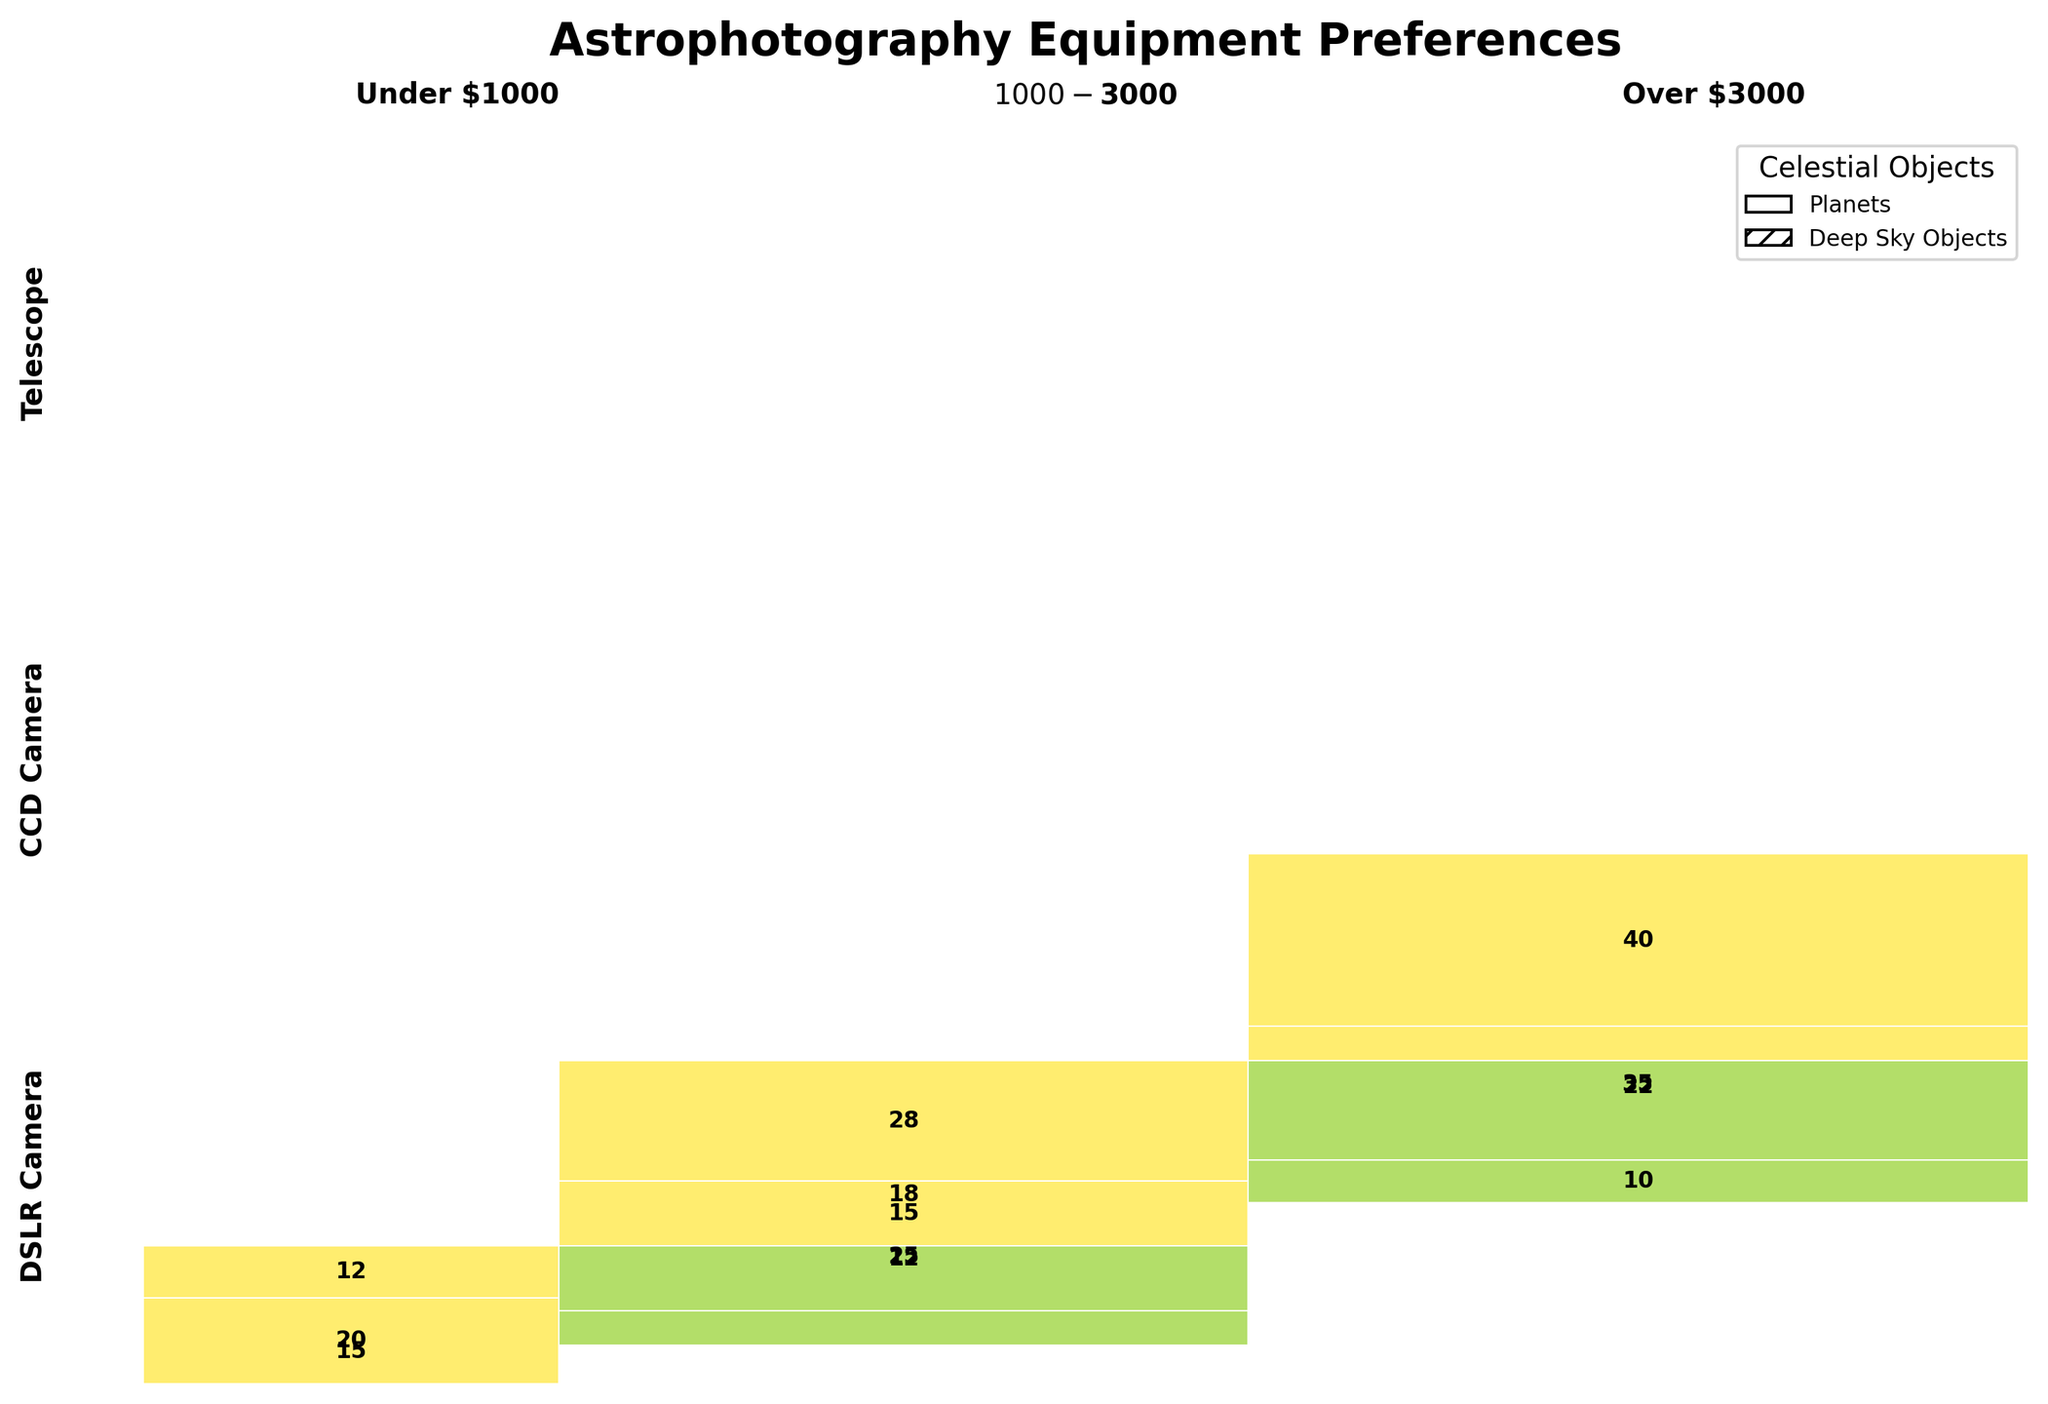What is the total number of DSLR Cameras used for capturing Deep Sky Objects in the $1000-$3000 range? First, find the DSLR Camera section. Within this section, locate the $1000-$3000 price range subsection, and then find the data for Deep Sky Objects. The number is 18.
Answer: 18 Which price range has the highest total count for capturing Planets with telescopes? Look for the Telescope segment and identify the counts for Planets in each price range. Compare these numbers: Under $1000 (20), $1000-$3000 (15), Over $3000 (8). The highest is Under $1000.
Answer: Under $1000 How many artists use CCD Cameras priced over $3000 to capture Deep Sky Objects? Navigate to the CCD Cameras section, find the $3000 and above price range, and then identify the count for Deep Sky Objects, which is 35.
Answer: 35 What is the overall most preferred celestial object to capture, considering all equipment types and price ranges? Sum the counts for Planets and Deep Sky Objects across all sections. Deep Sky Objects (154) have a higher total count than Planets (96).
Answer: Deep Sky Objects Between DSLR Cameras and Telescopes, which equipment is more commonly used for capturing Deep Sky Objects in the $1000-$3000 price range? Find the counts in the $1000-$3000 price range for both DSLR Cameras (18) and Telescopes (28). Compare these numbers. Telescopes have a higher count.
Answer: Telescopes Which combination of equipment type and price range has the smallest number of counts for Planets? Find the row with the smallest count for Planets. The smallest value appears to be for CCD Camera under $1000, which is 3.
Answer: CCD Camera under $1000 What is the most popular equipment type for capturing Deep Sky Objects across all price ranges? Sum the counts for Deep Sky Objects for each equipment type. Telescopes (80) have the highest summed count.
Answer: Telescopes How many artists use any equipment priced under $1000 for astrophotography? Sum the counts for all equipment types in the under $1000 price range: (15 + 8 + 3 + 6 + 20 + 12) = 64.
Answer: 64 Comparing DSLR Cameras and CCD Cameras, which has a higher total count across all price ranges for Deep Sky Objects only? Sum the counts for Deep Sky Objects for DSLR Cameras (8 Under $1000, 18 $1000-$3000, 22 Over $3000; total 48) and CCD Cameras (6 Under $1000, 25 $1000-$3000, 35 Over $3000; total 66). CCD Cameras have a higher count.
Answer: CCD Cameras 